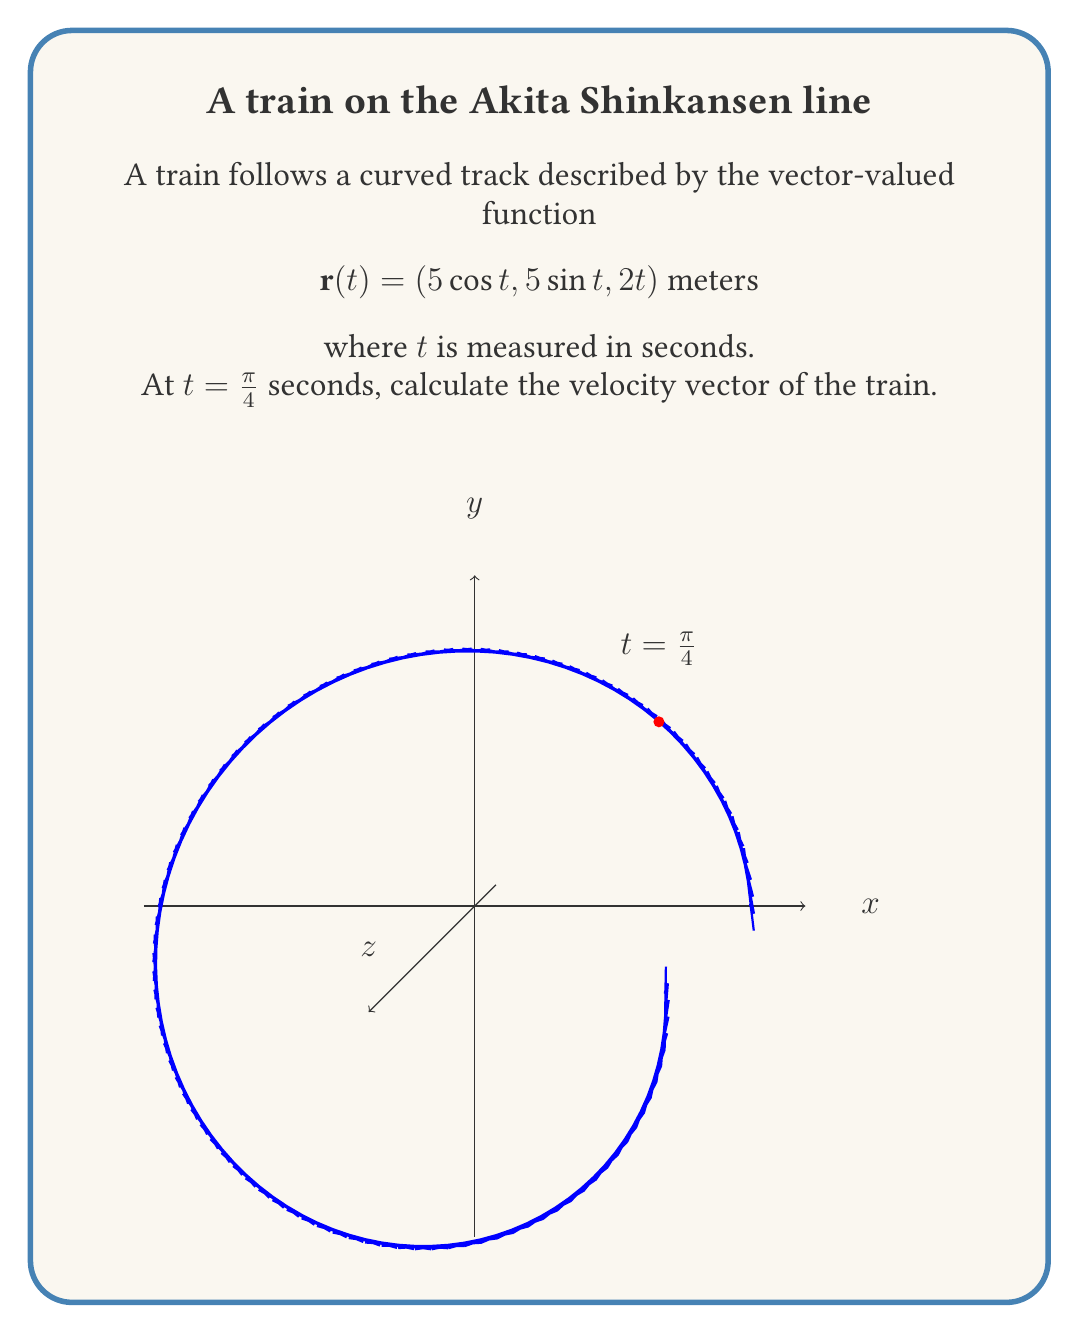Could you help me with this problem? To find the velocity vector, we need to differentiate the position vector $\mathbf{r}(t)$ with respect to time:

1) The position vector is given as:
   $$\mathbf{r}(t) = (5\cos t, 5\sin t, 2t)$$

2) The velocity vector is the derivative of the position vector:
   $$\mathbf{v}(t) = \frac{d\mathbf{r}}{dt} = \left(\frac{dx}{dt}, \frac{dy}{dt}, \frac{dz}{dt}\right)$$

3) Differentiating each component:
   $$\frac{dx}{dt} = -5\sin t$$
   $$\frac{dy}{dt} = 5\cos t$$
   $$\frac{dz}{dt} = 2$$

4) Therefore, the velocity vector is:
   $$\mathbf{v}(t) = (-5\sin t, 5\cos t, 2)$$

5) At $t = \frac{\pi}{4}$:
   $$\mathbf{v}(\frac{\pi}{4}) = \left(-5\sin(\frac{\pi}{4}), 5\cos(\frac{\pi}{4}), 2\right)$$

6) Simplify:
   $$\mathbf{v}(\frac{\pi}{4}) = \left(-5\cdot\frac{\sqrt{2}}{2}, 5\cdot\frac{\sqrt{2}}{2}, 2\right)$$
   $$= \left(-\frac{5\sqrt{2}}{2}, \frac{5\sqrt{2}}{2}, 2\right)$$

Thus, the velocity vector at $t = \frac{\pi}{4}$ seconds is $\left(-\frac{5\sqrt{2}}{2}, \frac{5\sqrt{2}}{2}, 2\right)$ meters per second.
Answer: $\left(-\frac{5\sqrt{2}}{2}, \frac{5\sqrt{2}}{2}, 2\right)$ m/s 